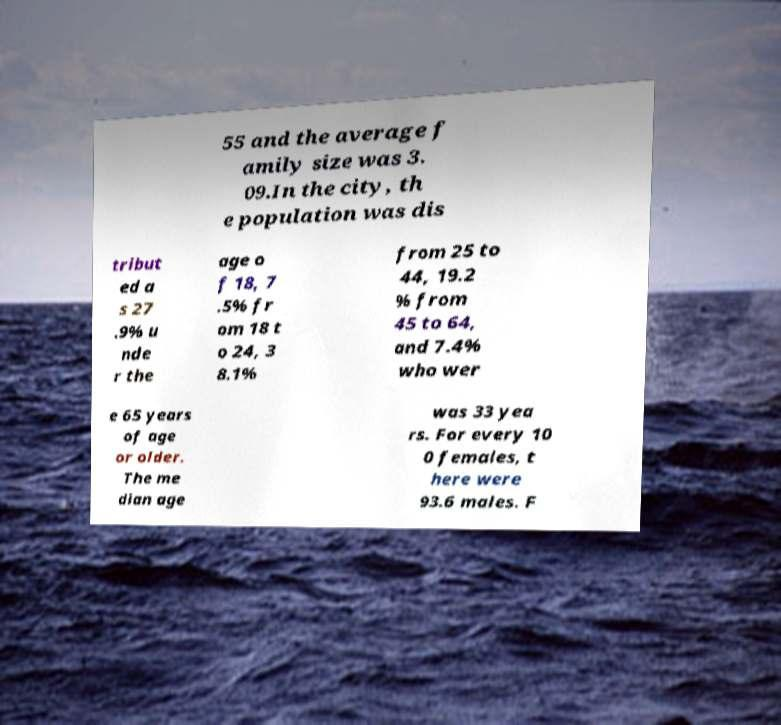I need the written content from this picture converted into text. Can you do that? 55 and the average f amily size was 3. 09.In the city, th e population was dis tribut ed a s 27 .9% u nde r the age o f 18, 7 .5% fr om 18 t o 24, 3 8.1% from 25 to 44, 19.2 % from 45 to 64, and 7.4% who wer e 65 years of age or older. The me dian age was 33 yea rs. For every 10 0 females, t here were 93.6 males. F 